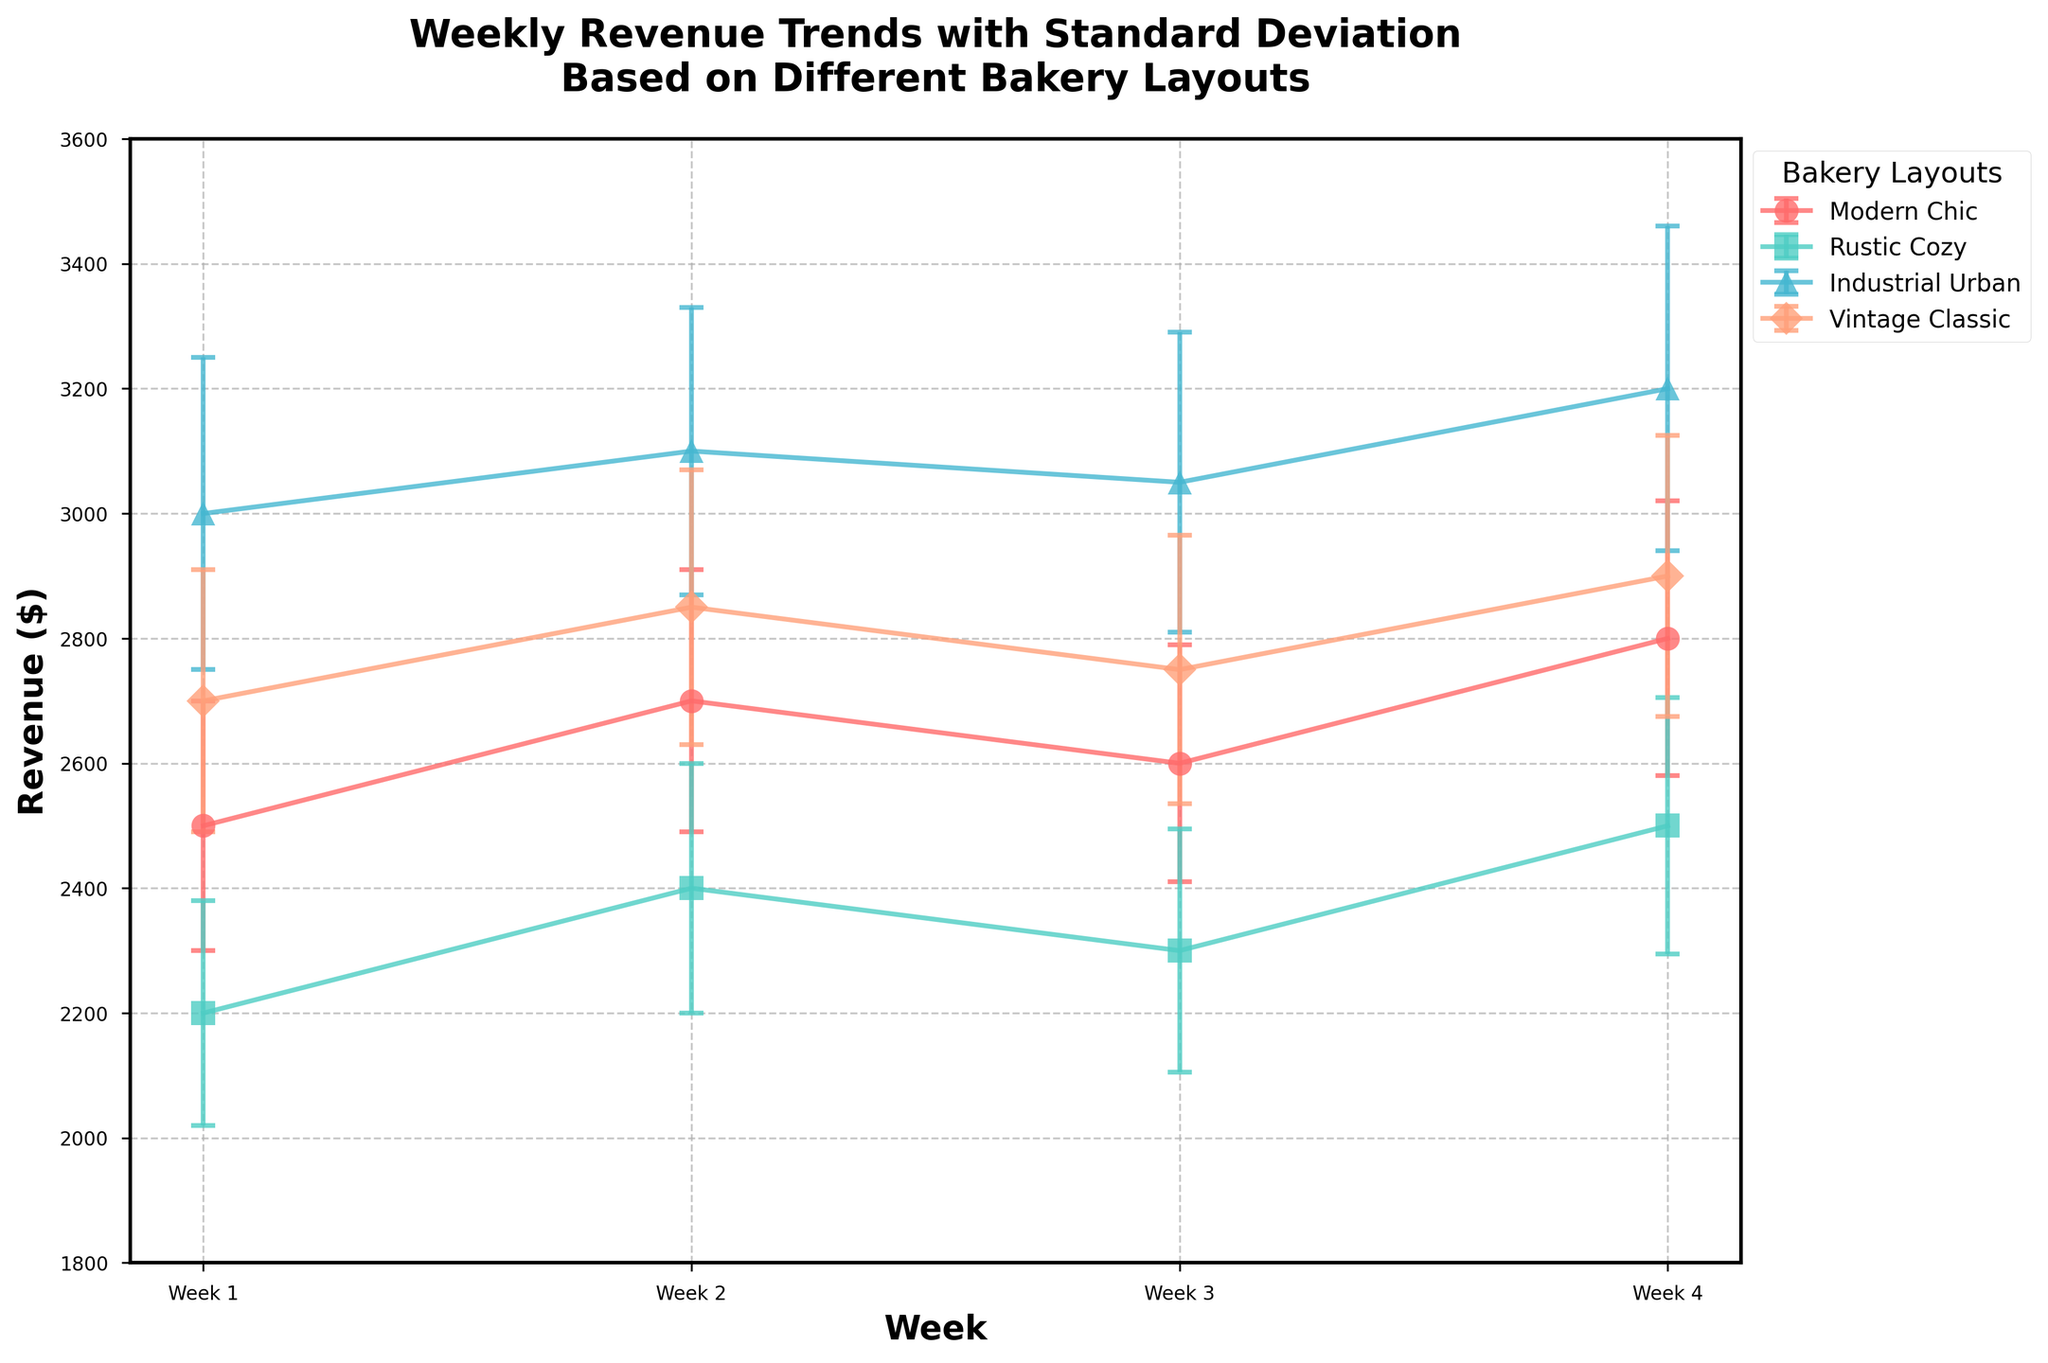What does the title of the plot indicate? The title of the plot is displayed at the top and it tells us that the plot is showing weekly revenue trends with standard deviation based on different bakery layouts. By looking at the title, we can understand that the focus is on how different layouts impact revenue over time.
Answer: Weekly Revenue Trends with Standard Deviation Based on Different Bakery Layouts How many weeks of revenue data are plotted for each bakery layout? By analyzing the x-axis, we can see labels for four weeks. Each line plot spans across these four weeks, indicating that revenue data for four weeks is plotted for each layout.
Answer: 4 weeks Which bakery layout had the highest revenue in week 2? To identify the highest revenue in week 2, we look at the points for week 2 on the plot. The Industrial Urban layout has the highest point in week 2, indicating the highest revenue.
Answer: Industrial Urban Which layout shows the highest overall revenue trend across the weeks? By assessing the overall height of the lines, the Industrial Urban layout’s line is consistently higher than the others, indicating the highest overall revenue trend across the weeks.
Answer: Industrial Urban What's the revenue difference between the Modern Chic and Rustic Cozy layouts in week 4? We locate the revenue points for both Modern Chic and Rustic Cozy layouts at week 4. Modern Chic has a revenue of $2800 and Rustic Cozy has $2500. The difference is $2800 - $2500 = $300.
Answer: $300 Which layout has the smallest standard deviation in week 3, and what does it imply? To find the smallest standard deviation, we look at the length of the error bars at week 3. The Modern Chic layout has the smallest error bar, indicating the smallest standard deviation. This implies that its revenue data is more consistent in week 3.
Answer: Modern Chic What is the average revenue of the Vintage Classic layout across the four weeks? We sum the revenue values for Vintage Classic across the four weeks: 2700 + 2850 + 2750 + 2900 and then divide by the number of weeks, 4. So, (2700 + 2850 + 2750 + 2900) / 4 = 2800.
Answer: $2800 How does the revenue trend of the Rustic Cozy layout compare with the Industrial Urban layout over the four weeks? We observe that the revenue for Rustic Cozy starts lower and increases steadily, while Industrial Urban starts higher and shows slight variations but remains consistently higher throughout. The trend indicates Industrial Urban has superior performance overall despite variances.
Answer: Industrial Urban > Rustic Cozy 